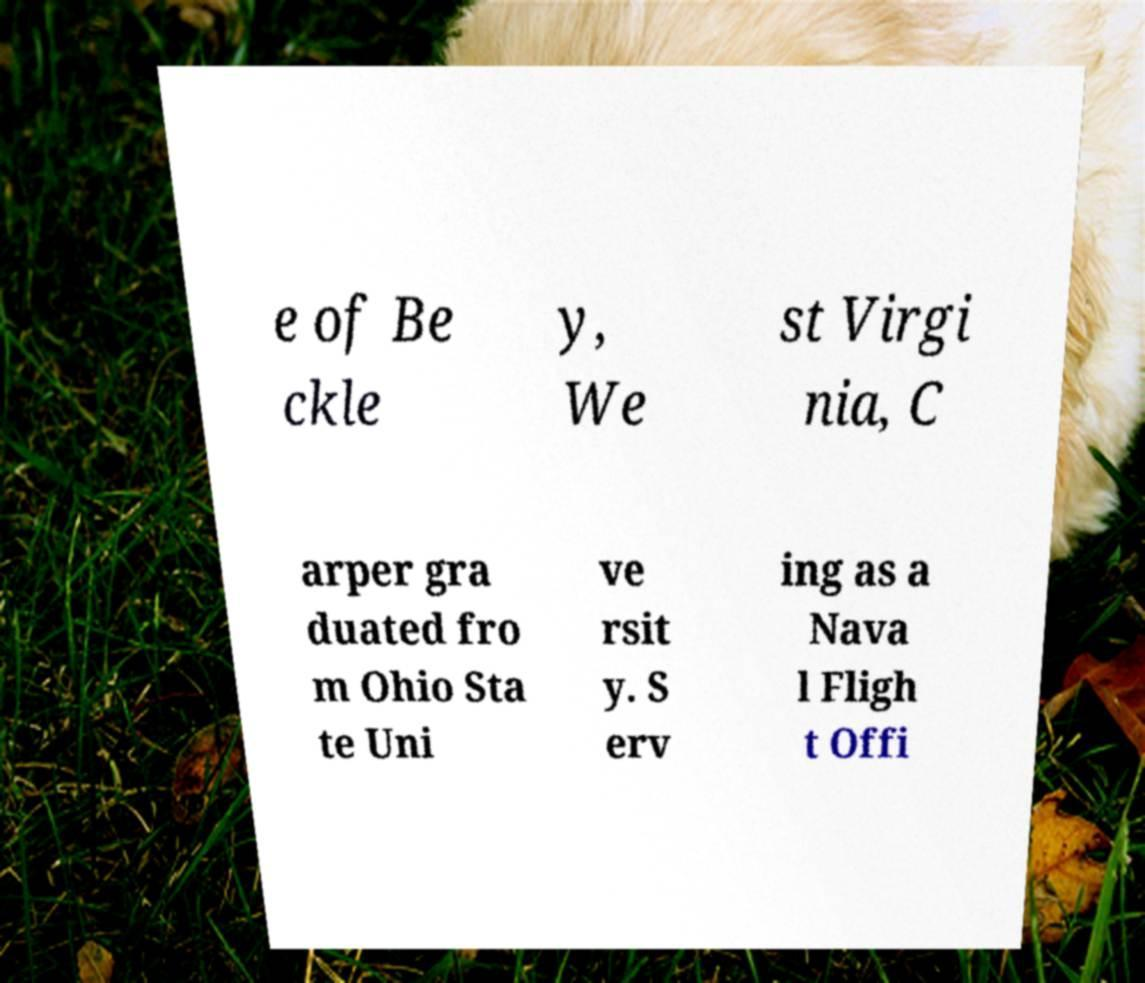Please identify and transcribe the text found in this image. e of Be ckle y, We st Virgi nia, C arper gra duated fro m Ohio Sta te Uni ve rsit y. S erv ing as a Nava l Fligh t Offi 